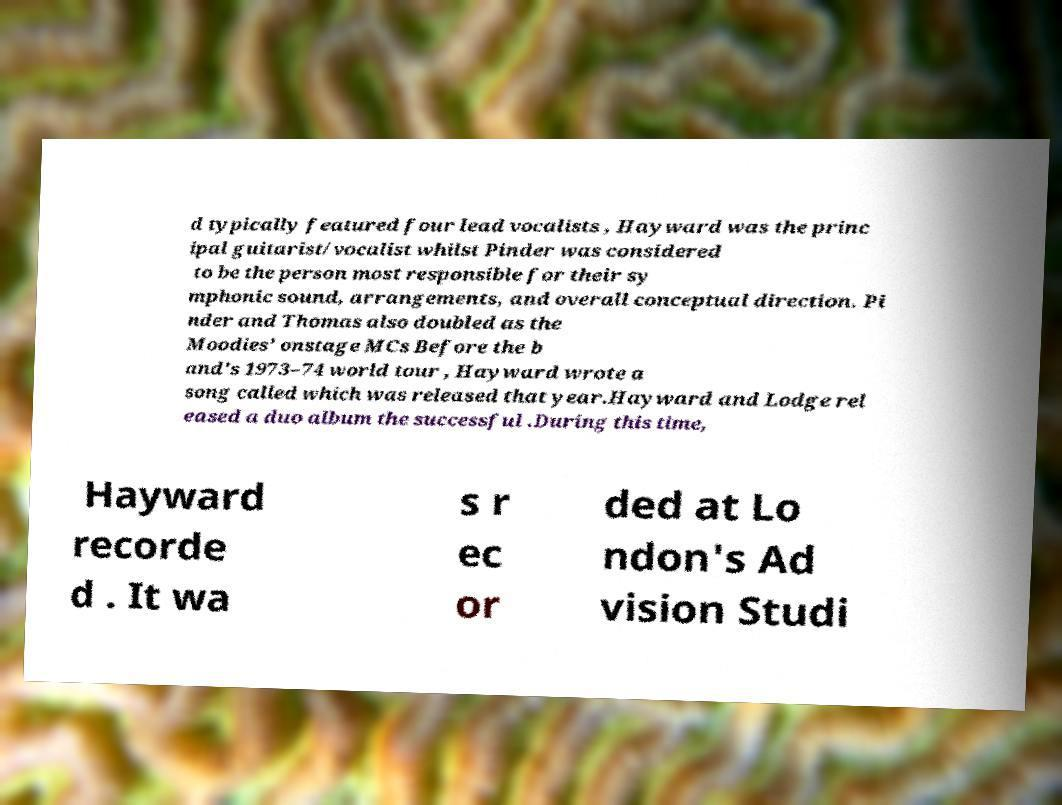What messages or text are displayed in this image? I need them in a readable, typed format. d typically featured four lead vocalists , Hayward was the princ ipal guitarist/vocalist whilst Pinder was considered to be the person most responsible for their sy mphonic sound, arrangements, and overall conceptual direction. Pi nder and Thomas also doubled as the Moodies' onstage MCs Before the b and's 1973–74 world tour , Hayward wrote a song called which was released that year.Hayward and Lodge rel eased a duo album the successful .During this time, Hayward recorde d . It wa s r ec or ded at Lo ndon's Ad vision Studi 